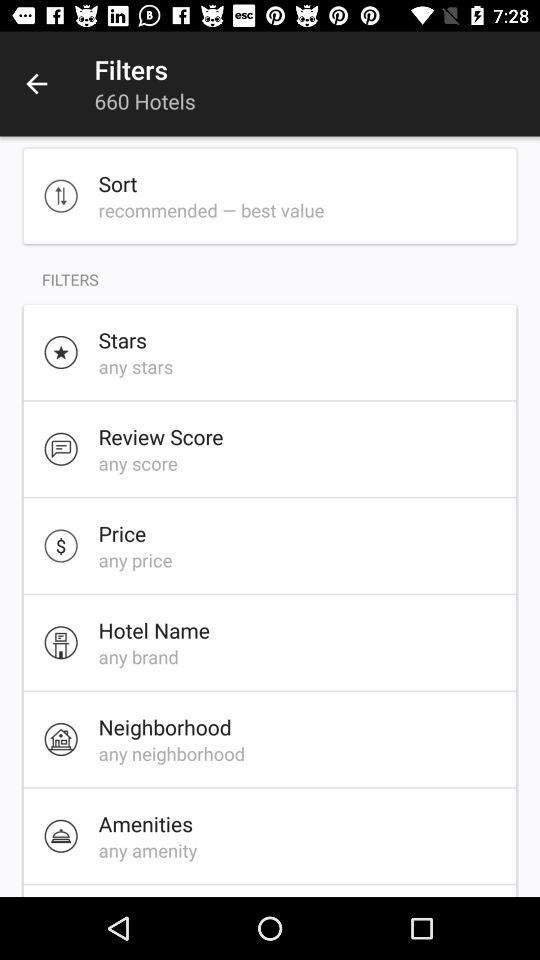What is the selected price? The selected price is "any price". 